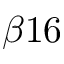<formula> <loc_0><loc_0><loc_500><loc_500>\beta 1 6</formula> 